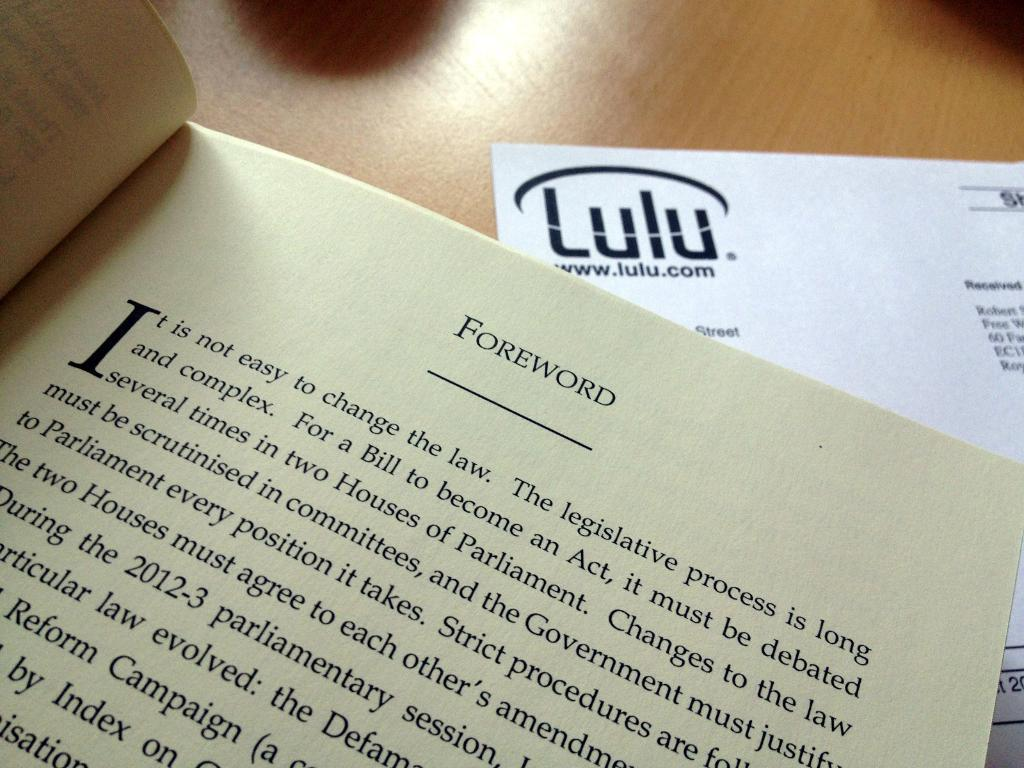Provide a one-sentence caption for the provided image. A book about government legislation is open to the forward page. 